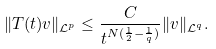Convert formula to latex. <formula><loc_0><loc_0><loc_500><loc_500>\| T ( t ) v \| _ { \mathcal { L } ^ { p } } \leq \frac { C } { t ^ { N ( \frac { 1 } { 2 } - \frac { 1 } { q } ) } } \| v \| _ { \mathcal { L } ^ { q } } .</formula> 